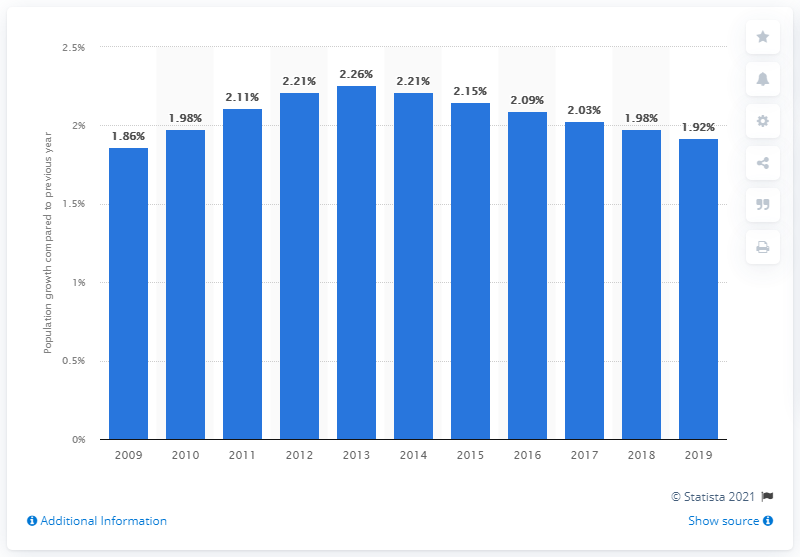Identify some key points in this picture. In 2019, Egypt's population increased by 1.92%. 